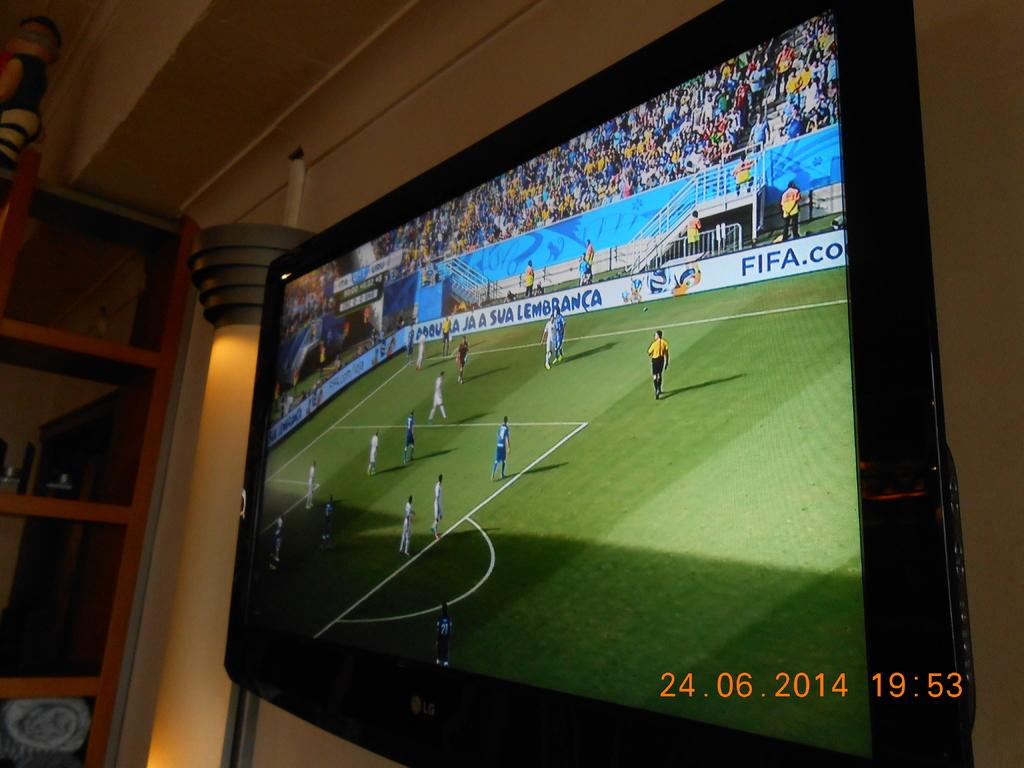<image>
Relay a brief, clear account of the picture shown. The picture was taken on June 24, 2014. 